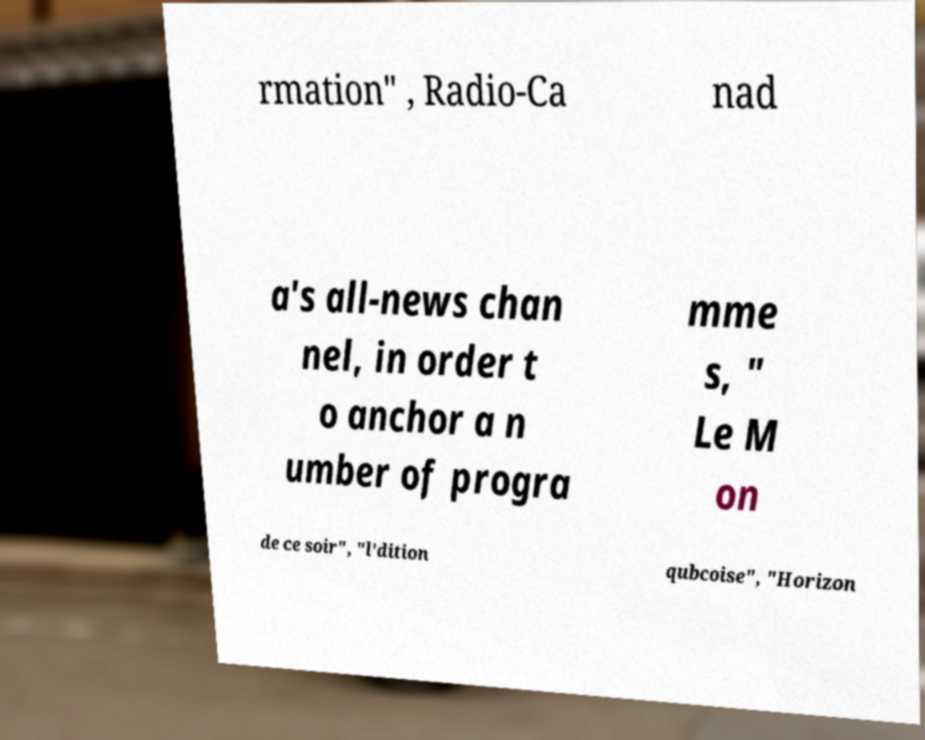Please read and relay the text visible in this image. What does it say? rmation" , Radio-Ca nad a's all-news chan nel, in order t o anchor a n umber of progra mme s, " Le M on de ce soir", "l'dition qubcoise", "Horizon 